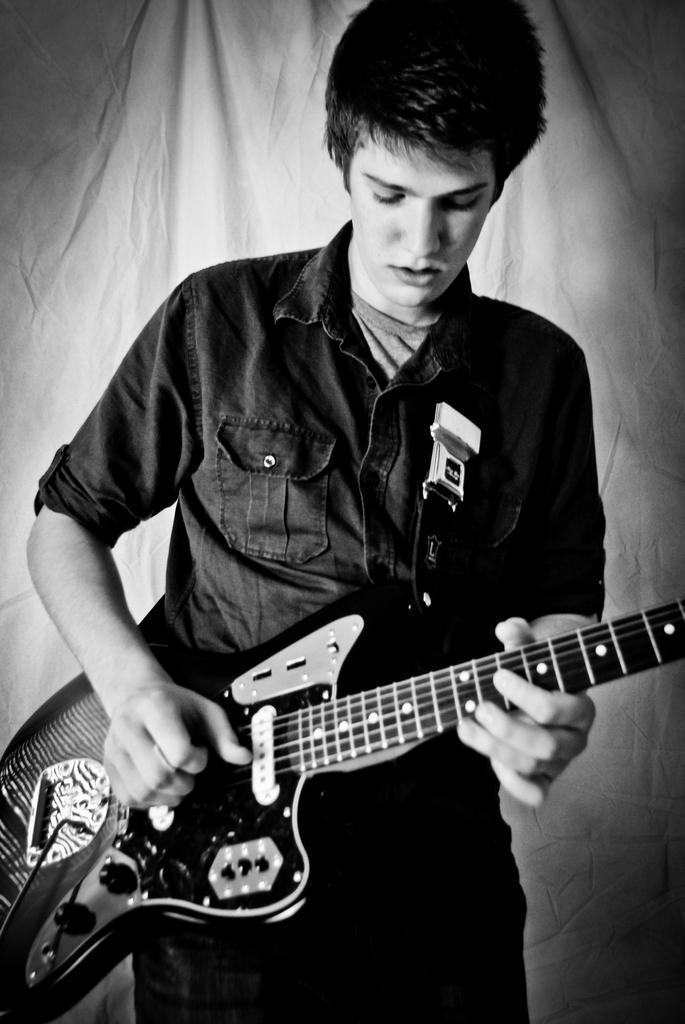In one or two sentences, can you explain what this image depicts? In this image I see a man who is standing and holding guitar. 